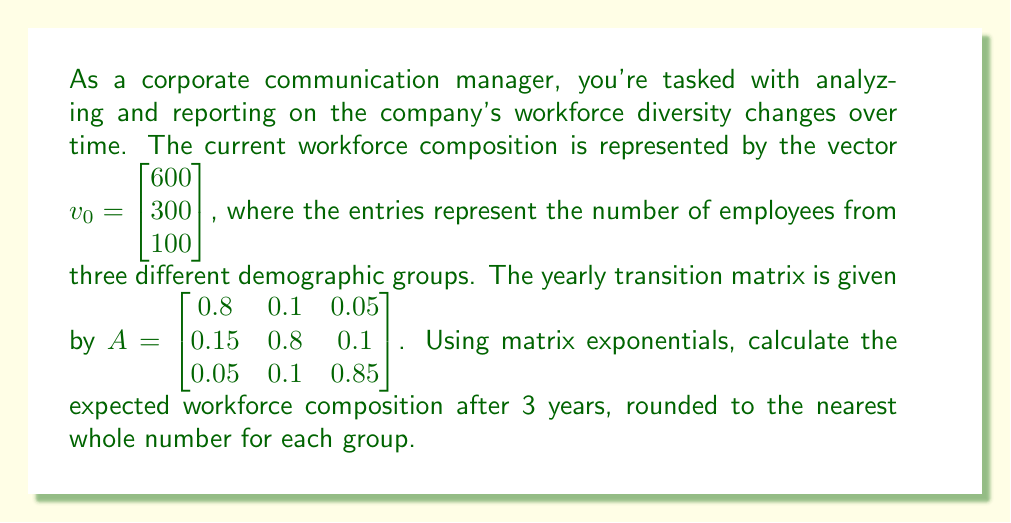Show me your answer to this math problem. To solve this problem, we'll use the matrix exponential method:

1) The formula for workforce composition after t years is:
   $v_t = e^{tA} v_0$

2) We need to calculate $e^{3A}$. We can use the power series expansion:
   $e^{3A} = I + 3A + \frac{(3A)^2}{2!} + \frac{(3A)^3}{3!} + ...$

3) Let's calculate the first few terms:
   $3A = \begin{bmatrix} 2.4 & 0.3 & 0.15 \\ 0.45 & 2.4 & 0.3 \\ 0.15 & 0.3 & 2.55 \end{bmatrix}$

   $(3A)^2 = \begin{bmatrix} 5.9175 & 1.485 & 0.8925 \\ 2.2275 & 5.9175 & 1.485 \\ 0.8925 & 1.485 & 6.63 \end{bmatrix}$

4) Approximating $e^{3A}$ with the first three terms:
   $e^{3A} \approx I + 3A + \frac{(3A)^2}{2}$
   
   $= \begin{bmatrix} 1 & 0 & 0 \\ 0 & 1 & 0 \\ 0 & 0 & 1 \end{bmatrix} + \begin{bmatrix} 2.4 & 0.3 & 0.15 \\ 0.45 & 2.4 & 0.3 \\ 0.15 & 0.3 & 2.55 \end{bmatrix} + \frac{1}{2}\begin{bmatrix} 5.9175 & 1.485 & 0.8925 \\ 2.2275 & 5.9175 & 1.485 \\ 0.8925 & 1.485 & 6.63 \end{bmatrix}$

   $\approx \begin{bmatrix} 6.35875 & 1.0425 & 0.59625 \\ 1.56375 & 6.35875 & 1.0425 \\ 0.59625 & 1.0425 & 6.865 \end{bmatrix}$

5) Now we multiply this by $v_0$:
   $v_3 \approx \begin{bmatrix} 6.35875 & 1.0425 & 0.59625 \\ 1.56375 & 6.35875 & 1.0425 \\ 0.59625 & 1.0425 & 6.865 \end{bmatrix} \begin{bmatrix} 600 \\ 300 \\ 100 \end{bmatrix}$

6) Performing the matrix multiplication:
   $v_3 \approx \begin{bmatrix} 4015.5 \\ 1238.25 \\ 746.25 \end{bmatrix}$

7) Rounding to the nearest whole number:
   $v_3 \approx \begin{bmatrix} 4016 \\ 1238 \\ 746 \end{bmatrix}$
Answer: $\begin{bmatrix} 4016 \\ 1238 \\ 746 \end{bmatrix}$ 